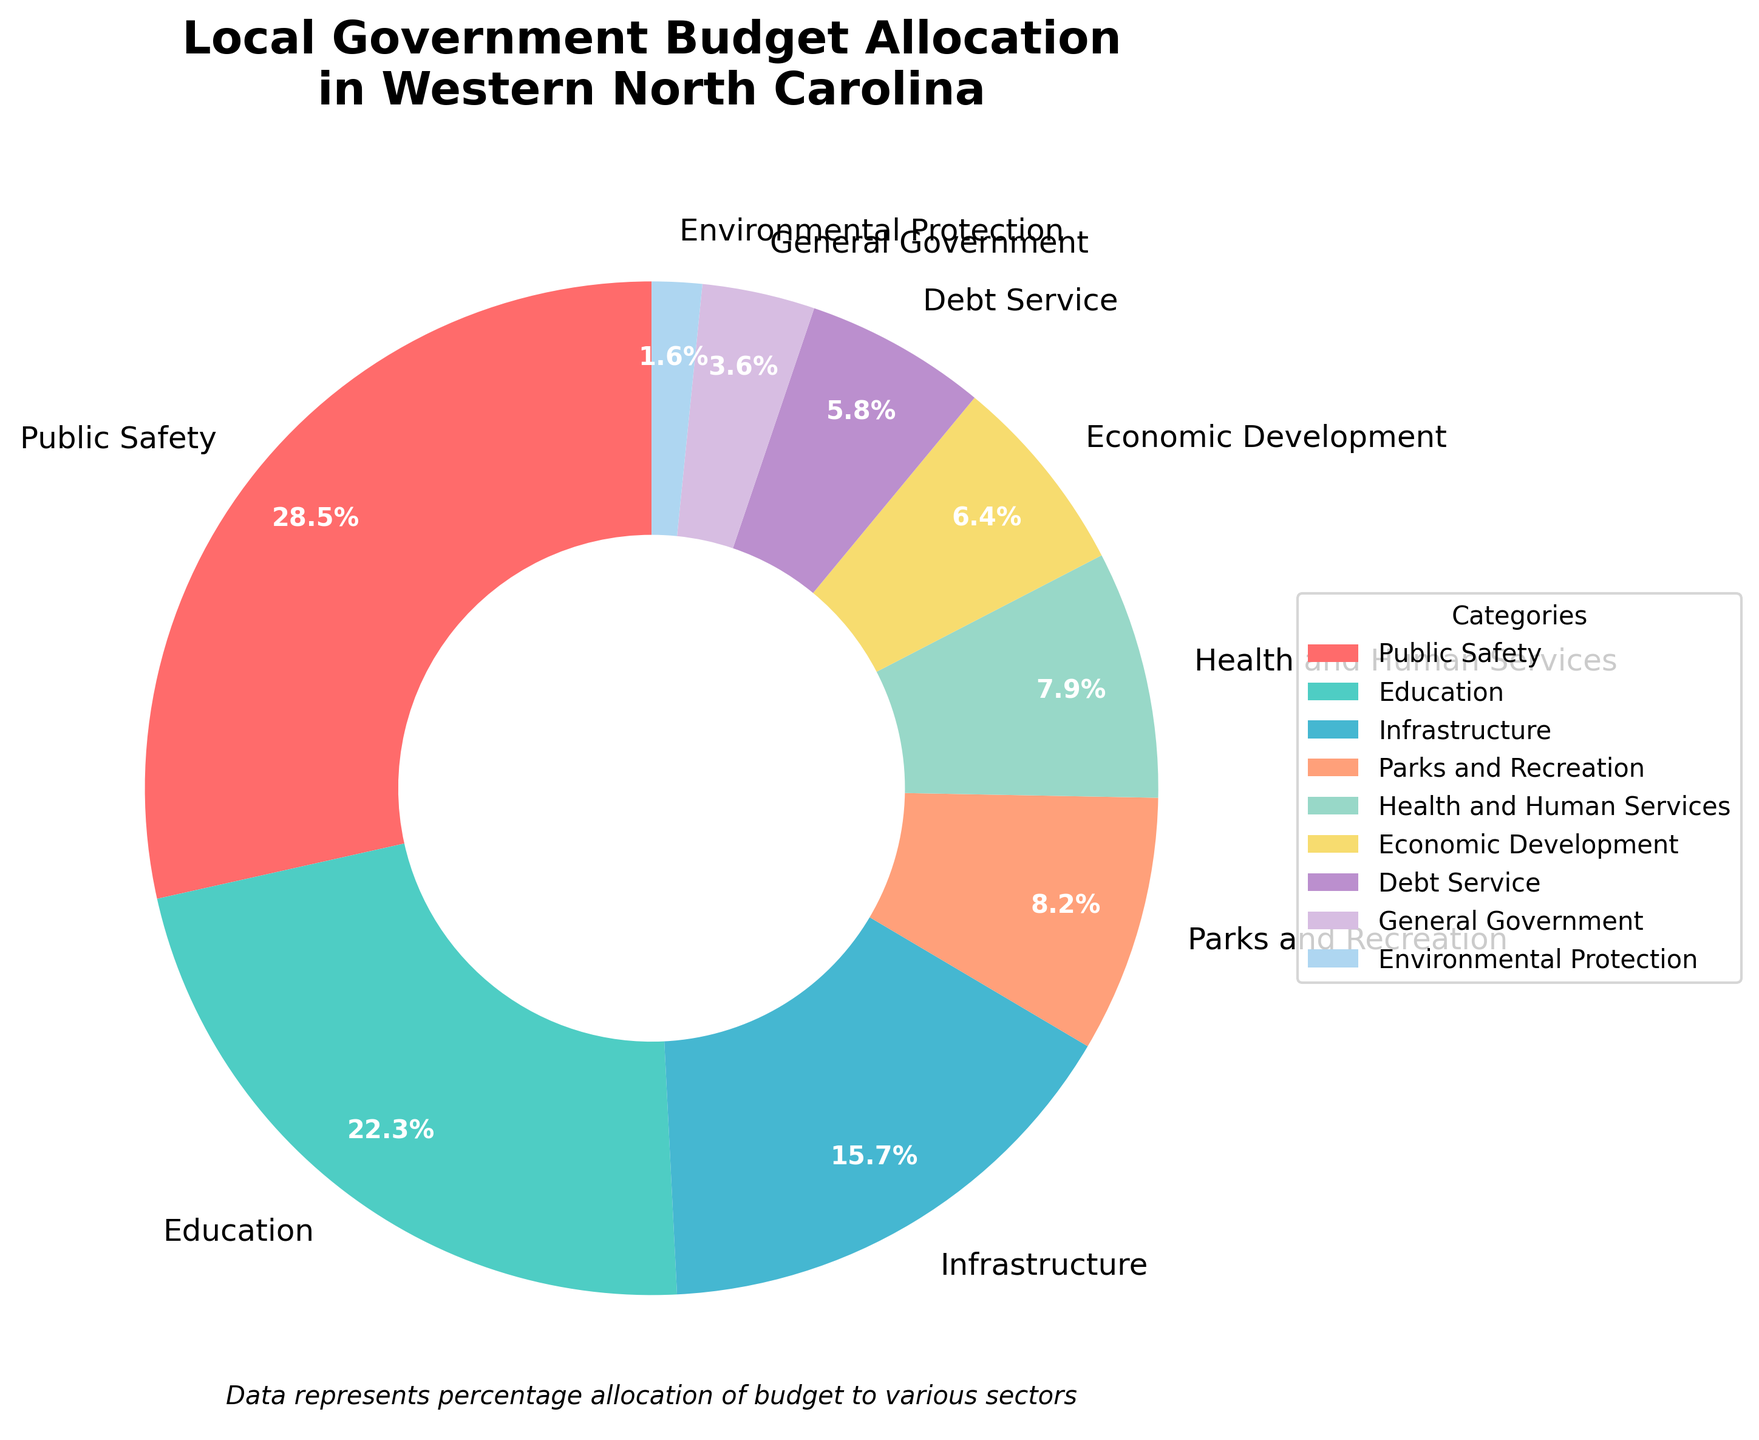What's the largest allocation category? The largest allocation category is easily seen as the wedge with the highest percentage. From the pie chart, "Public Safety" takes up the largest portion.
Answer: Public Safety Which category has nearly one-fifth of the budget? One-fifth of the budget is 20%. Looking at the chart, "Education" has the percentage closest to 20%.
Answer: Education What is the combined budget allocation for Health and Human Services and Economic Development? Health and Human Services are allocated 7.9%, and Economic Development is allocated 6.4%. Adding these up gives 7.9% + 6.4% = 14.3%.
Answer: 14.3% Compare the budget allocation for Infrastructure and Public Safety, which one is greater and by how much? Public Safety is 28.5% and Infrastructure is 15.7%. The difference is calculated as 28.5% - 15.7% = 12.8%. Therefore, Public Safety has 12.8% more allocation than Infrastructure.
Answer: Public Safety by 12.8% Which categories have less than 10% allocation each? By examining the length of each wedge, we can identify those with less than 10%: "Parks and Recreation", "Health and Human Services", "Economic Development", "Debt Service", "General Government", and "Environmental Protection" are all under 10%.
Answer: Parks and Recreation, Health and Human Services, Economic Development, Debt Service, General Government, Environmental Protection What percentage of the budget is allocated to General Government relative to the total budget? General Government is allocated 3.6%. Since this is a pie chart, the percentages are given relative to the total budget. Therefore, 3.6% is exactly 3.6% of the total budget.
Answer: 3.6% How does the budget allocation for Debt Service compare to that of Health and Human Services? Debt Service is at 5.8% and Health and Human Services is at 7.9%. Therefore, Debt Service is less by 7.9% - 5.8% = 2.1%.
Answer: Debt Service is 2.1% less than Health and Human Services What is the total percentage of the budget allocated to Education, Infrastructure, and Parks and Recreation? Adding their percentages: Education (22.3%) + Infrastructure (15.7%) + Parks and Recreation (8.2%) = 46.2%.
Answer: 46.2% Which category is the smallest in terms of budget allocation? The smallest slice of the pie is easily seen to be "Environmental Protection" at 1.6%.
Answer: Environmental Protection If the budget allocation for Public Safety and Education were combined, what fraction of the total budget would they represent? Public Safety is 28.5% and Education is 22.3%. Their combined percentage is 28.5% + 22.3% = 50.8%. This makes up 50.8% of the total budget.
Answer: 50.8% 